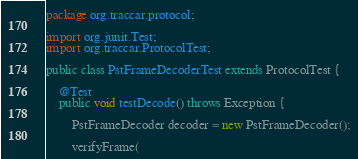Convert code to text. <code><loc_0><loc_0><loc_500><loc_500><_Java_>package org.traccar.protocol;

import org.junit.Test;
import org.traccar.ProtocolTest;

public class PstFrameDecoderTest extends ProtocolTest {

    @Test
    public void testDecode() throws Exception {

        PstFrameDecoder decoder = new PstFrameDecoder();

        verifyFrame(</code> 